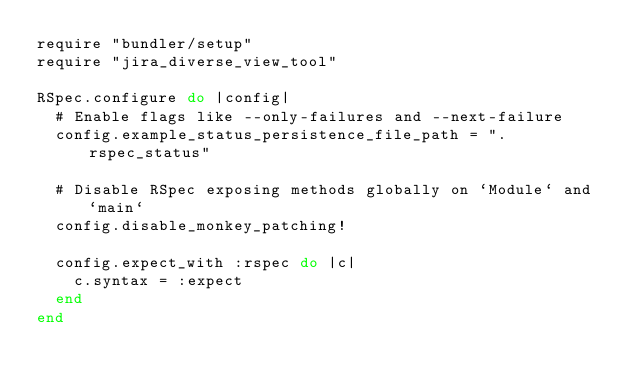Convert code to text. <code><loc_0><loc_0><loc_500><loc_500><_Ruby_>require "bundler/setup"
require "jira_diverse_view_tool"

RSpec.configure do |config|
  # Enable flags like --only-failures and --next-failure
  config.example_status_persistence_file_path = ".rspec_status"

  # Disable RSpec exposing methods globally on `Module` and `main`
  config.disable_monkey_patching!

  config.expect_with :rspec do |c|
    c.syntax = :expect
  end
end
</code> 